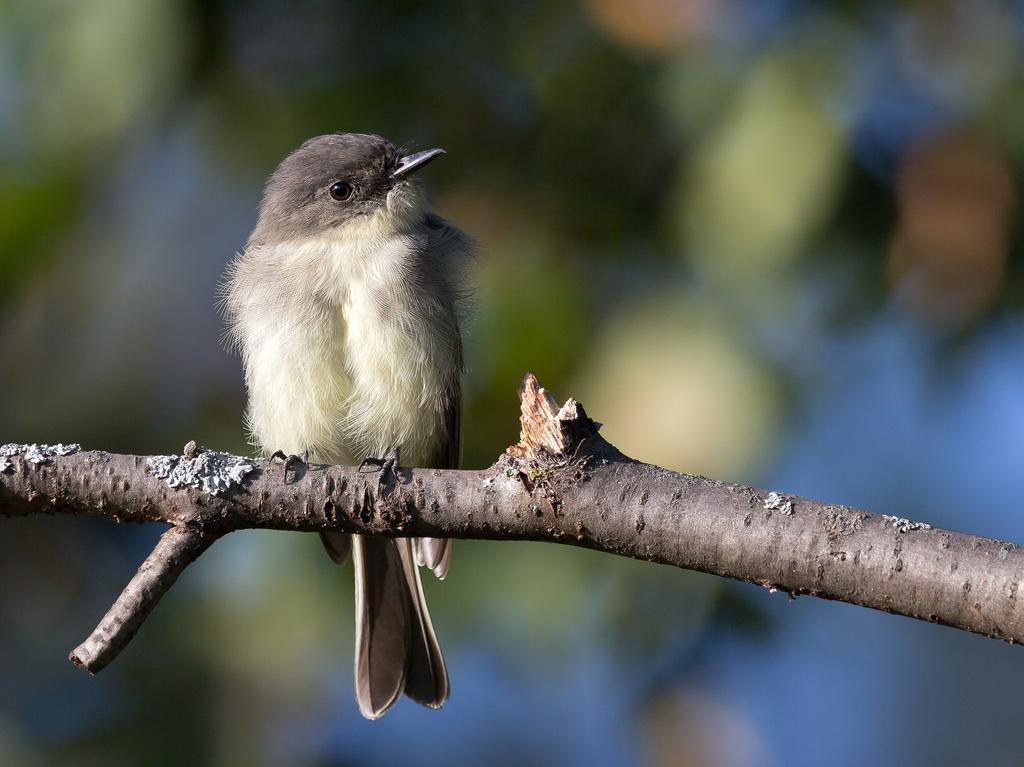Could you give a brief overview of what you see in this image? As we can see in the image, there is a bird standing on tree branch. It is in brown and white color. 